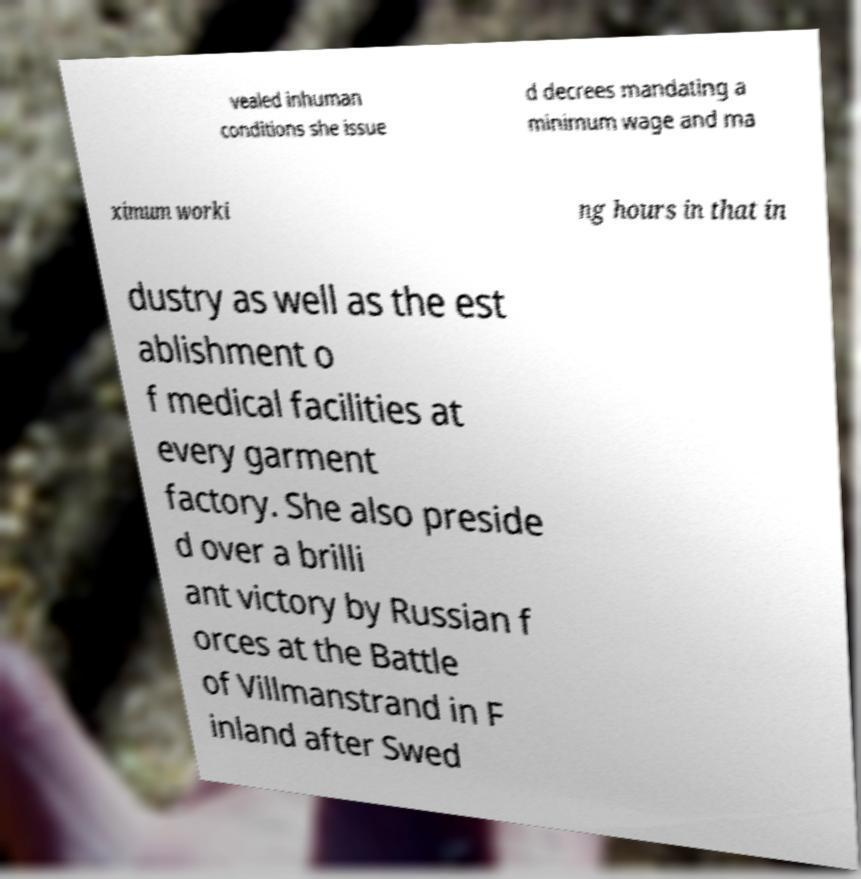Can you accurately transcribe the text from the provided image for me? vealed inhuman conditions she issue d decrees mandating a minimum wage and ma ximum worki ng hours in that in dustry as well as the est ablishment o f medical facilities at every garment factory. She also preside d over a brilli ant victory by Russian f orces at the Battle of Villmanstrand in F inland after Swed 